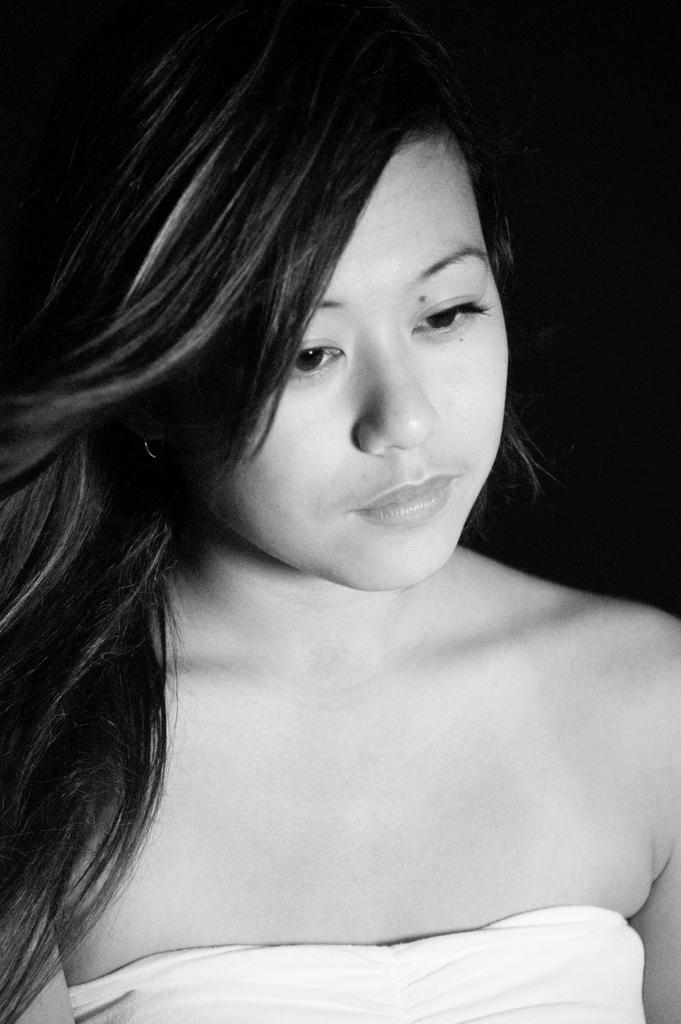What is the color scheme of the image? The image is black and white. Can you describe the main subject of the image? There is a girl in the image. What type of ring can be seen on the girl's finger in the image? There is no ring visible on the girl's finger in the image, as it is a black and white image and rings are typically not visible in such images. 